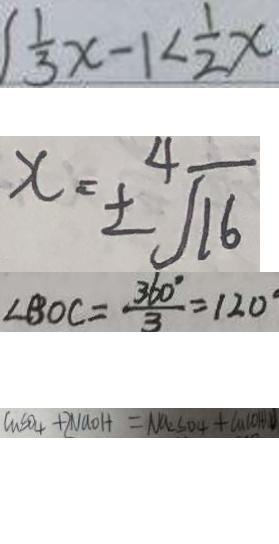<formula> <loc_0><loc_0><loc_500><loc_500>\frac { 1 } { 3 } x - 1 < \frac { 1 } { 2 } x 
 x = \pm \sqrt [ 4 ] { 1 6 } 
 \angle B O C = \frac { 3 6 0 ^ { \circ } } { 3 } = 1 2 0 ^ { \circ } 
 C u S O _ { 4 } + 2 N a O H = N a _ { 2 } S O _ { 4 } + C a ( O H ) D</formula> 